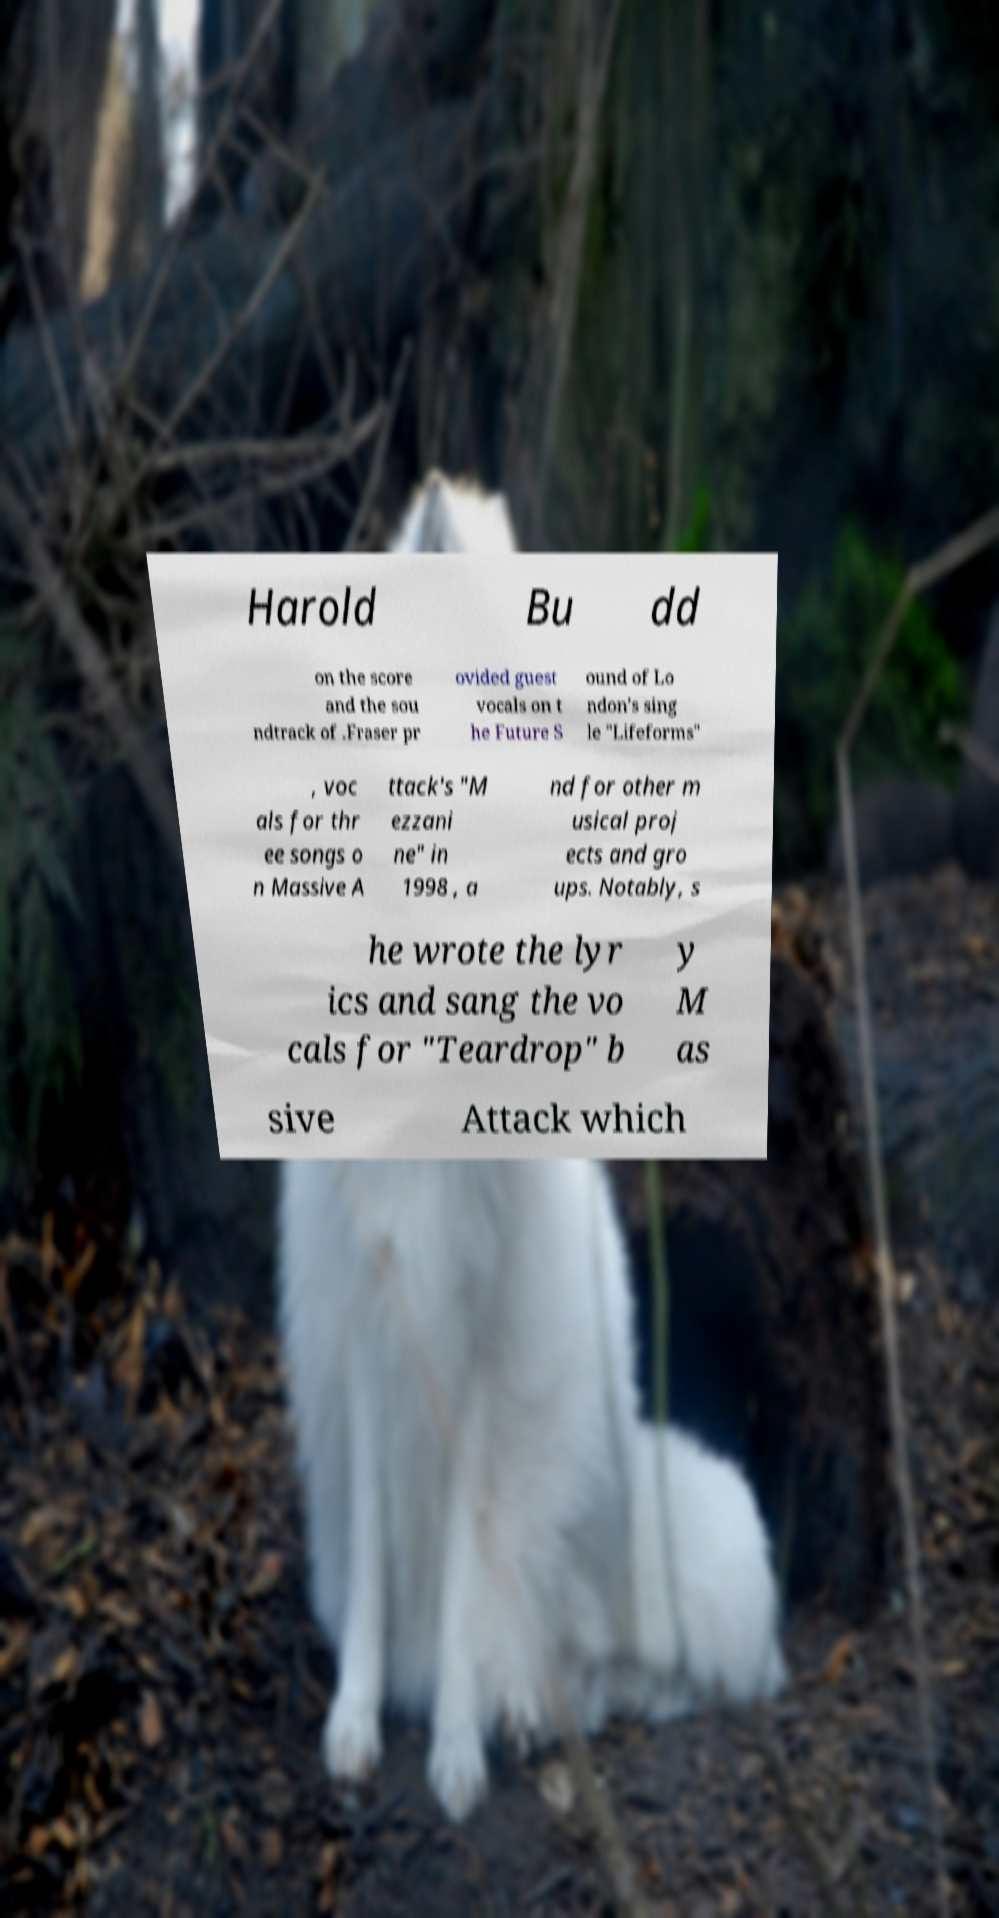I need the written content from this picture converted into text. Can you do that? Harold Bu dd on the score and the sou ndtrack of .Fraser pr ovided guest vocals on t he Future S ound of Lo ndon's sing le "Lifeforms" , voc als for thr ee songs o n Massive A ttack's "M ezzani ne" in 1998 , a nd for other m usical proj ects and gro ups. Notably, s he wrote the lyr ics and sang the vo cals for "Teardrop" b y M as sive Attack which 